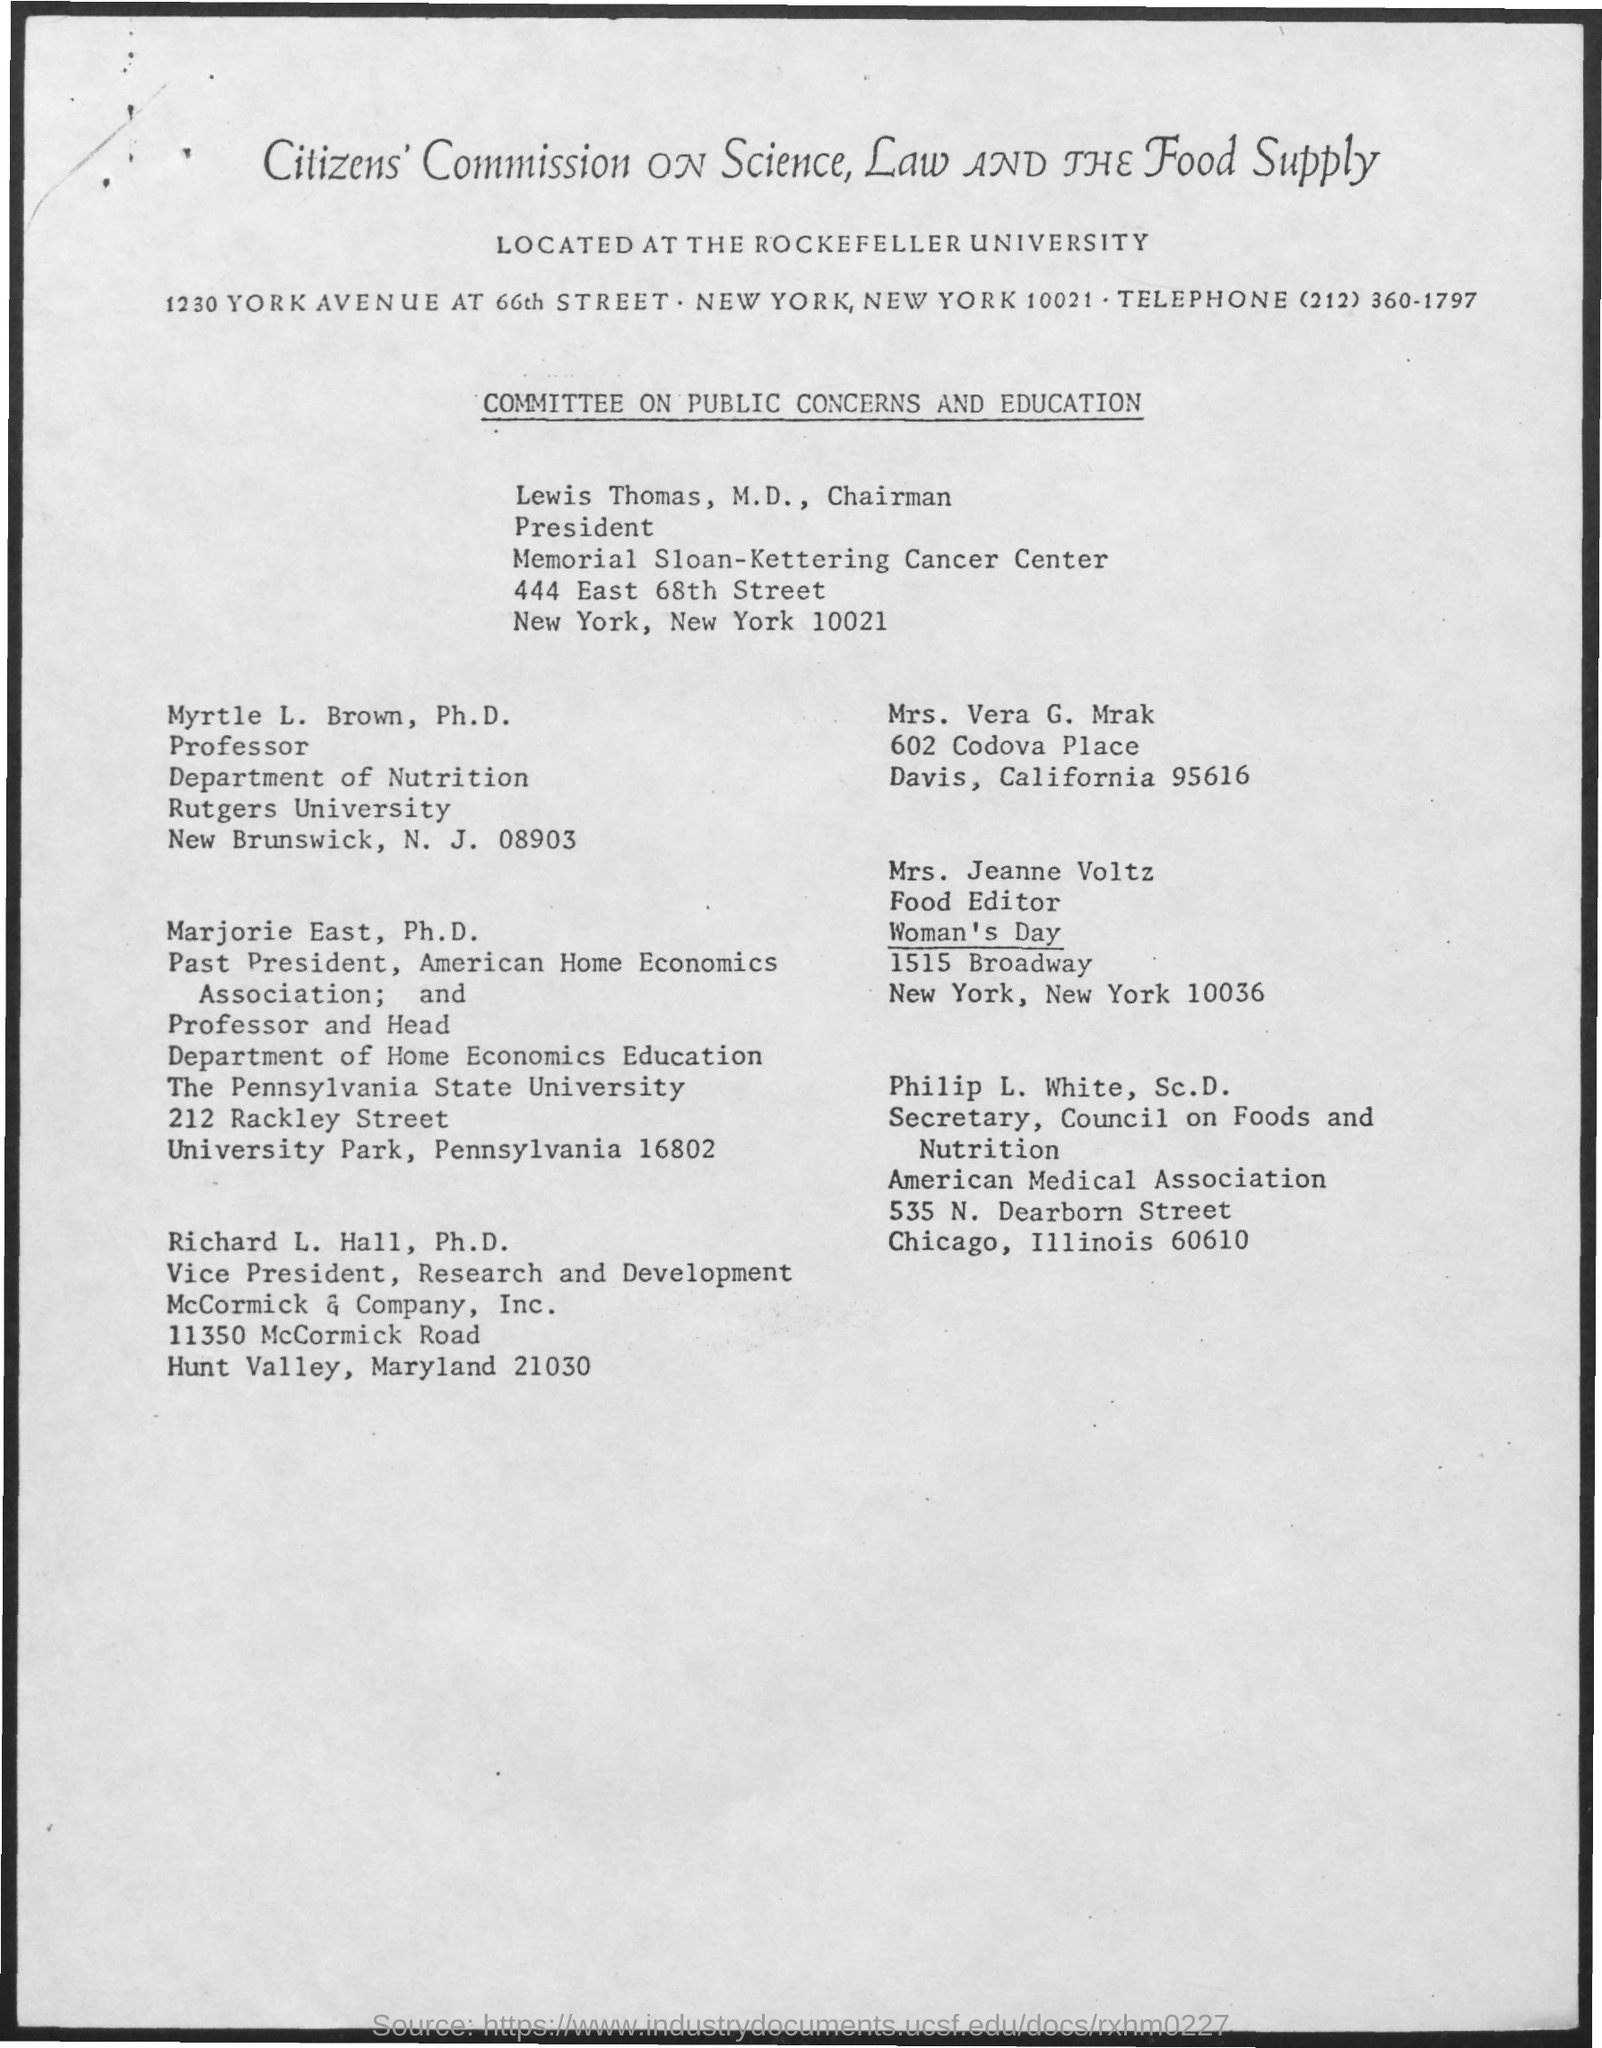What is the telephone no. mentioned in the given page ?
Offer a very short reply. (212) 360-1797. To which department myrtle l. brown belongs to?
Ensure brevity in your answer.  Department of Nutrition. To which university mrytle l.brown belongs to ?
Ensure brevity in your answer.  Rutgers university. 